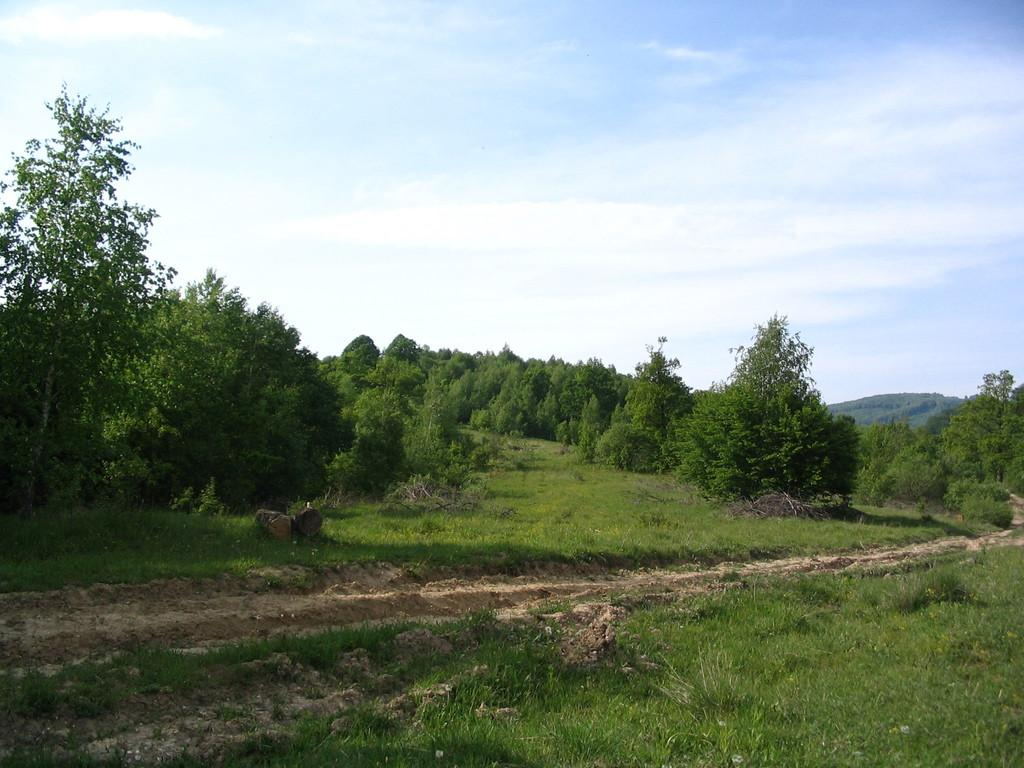What type of vegetation is present in the image? There is grass in the image. What other natural elements can be seen in the image? There are trees and a mountain in the image. What is visible in the sky in the image? There are clouds in the sky in the image. Where is the dock located in the image? There is no dock present in the image. What type of destruction can be seen in the image? There is no destruction present in the image; it features natural elements such as grass, trees, a mountain, and clouds. 